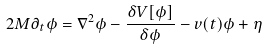Convert formula to latex. <formula><loc_0><loc_0><loc_500><loc_500>2 M \partial _ { t } \phi = \nabla ^ { 2 } \phi - \frac { \delta V [ \phi ] } { \delta \phi } - v ( t ) \phi + \eta</formula> 